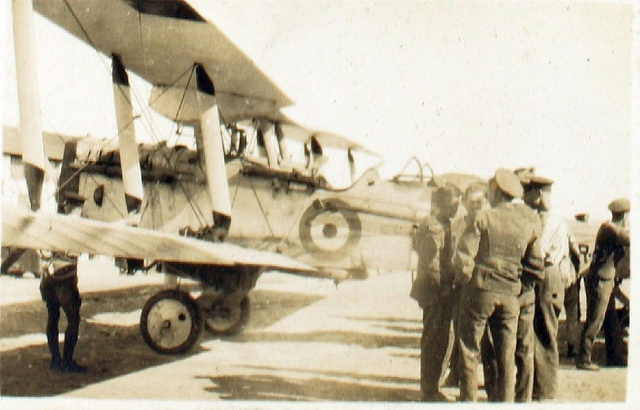Describe the objects in this image and their specific colors. I can see airplane in white, tan, beige, and black tones, people in white, tan, black, and gray tones, people in white, gray, black, tan, and olive tones, people in white, beige, tan, black, and gray tones, and people in white, black, tan, and gray tones in this image. 